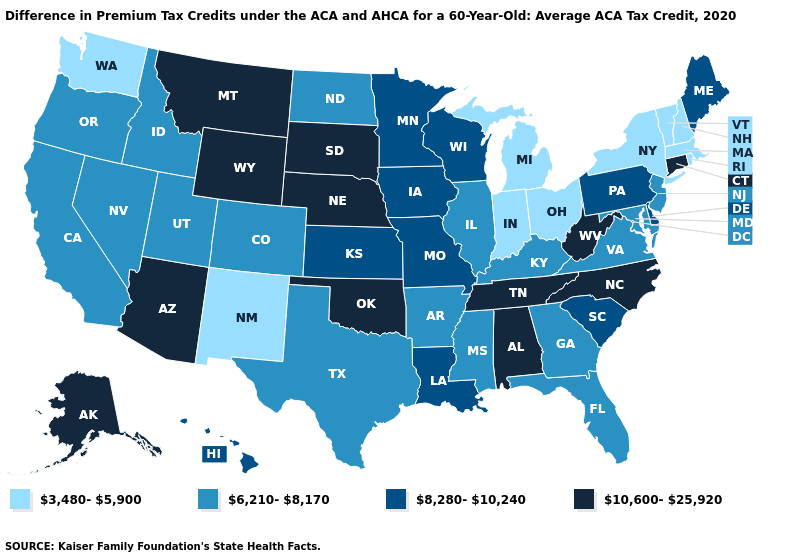Does Tennessee have the highest value in the USA?
Be succinct. Yes. Does the first symbol in the legend represent the smallest category?
Be succinct. Yes. Name the states that have a value in the range 6,210-8,170?
Quick response, please. Arkansas, California, Colorado, Florida, Georgia, Idaho, Illinois, Kentucky, Maryland, Mississippi, Nevada, New Jersey, North Dakota, Oregon, Texas, Utah, Virginia. Name the states that have a value in the range 3,480-5,900?
Short answer required. Indiana, Massachusetts, Michigan, New Hampshire, New Mexico, New York, Ohio, Rhode Island, Vermont, Washington. What is the highest value in states that border South Carolina?
Write a very short answer. 10,600-25,920. What is the lowest value in the MidWest?
Concise answer only. 3,480-5,900. What is the highest value in the USA?
Be succinct. 10,600-25,920. Does the map have missing data?
Keep it brief. No. What is the value of Arizona?
Answer briefly. 10,600-25,920. What is the value of Oregon?
Give a very brief answer. 6,210-8,170. Name the states that have a value in the range 3,480-5,900?
Keep it brief. Indiana, Massachusetts, Michigan, New Hampshire, New Mexico, New York, Ohio, Rhode Island, Vermont, Washington. Does the map have missing data?
Answer briefly. No. How many symbols are there in the legend?
Concise answer only. 4. Name the states that have a value in the range 6,210-8,170?
Keep it brief. Arkansas, California, Colorado, Florida, Georgia, Idaho, Illinois, Kentucky, Maryland, Mississippi, Nevada, New Jersey, North Dakota, Oregon, Texas, Utah, Virginia. What is the value of Minnesota?
Concise answer only. 8,280-10,240. 